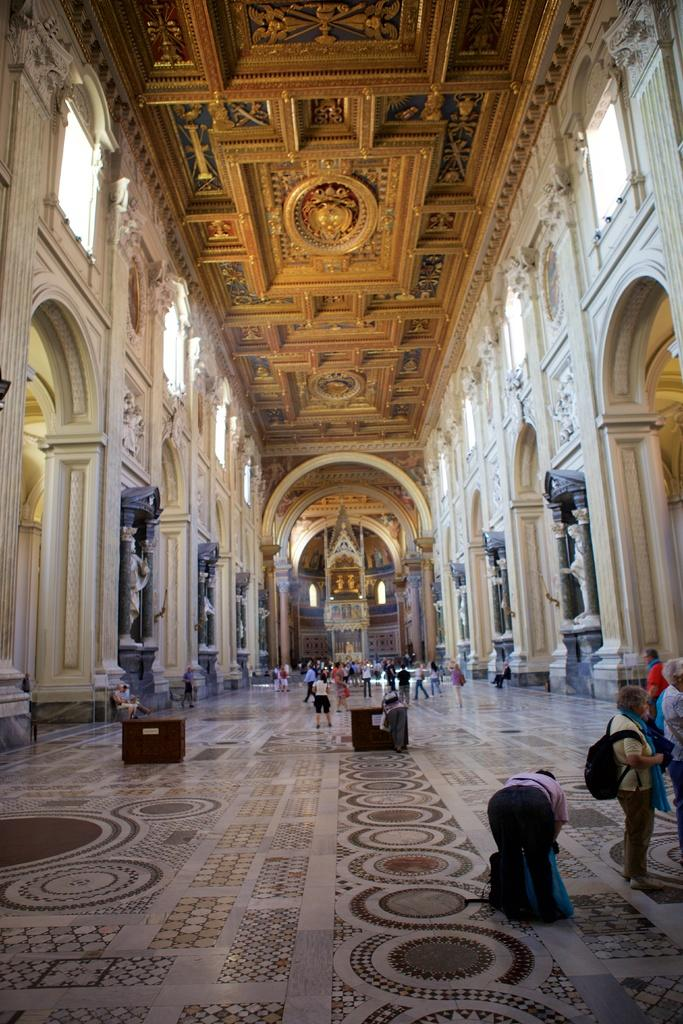What is the main setting of the image? The main setting of the image is inside a building. What type of furniture can be seen in the building? There are tables in the building. What part of the building is visible at the bottom of the image? The floor is visible at the bottom of the image. What type of powder is being used by the owner of the building in the image? There is no indication of any powder or owner in the image. 